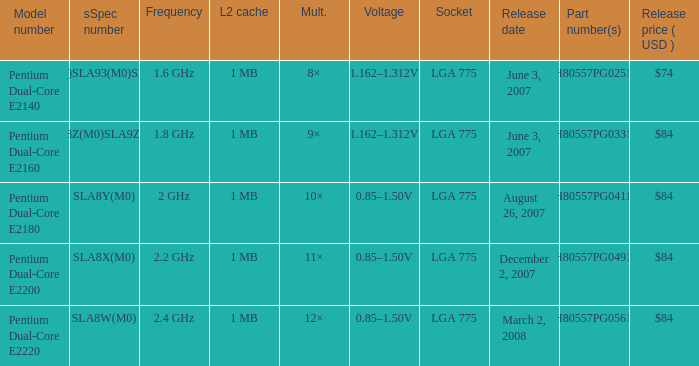What L2 cache had a release date of august 26, 2007? 1 MB. 